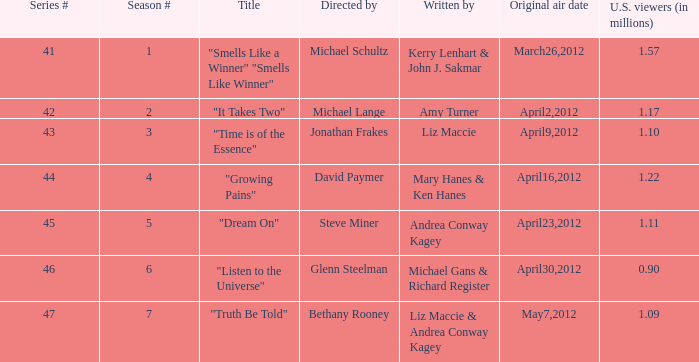Could you help me parse every detail presented in this table? {'header': ['Series #', 'Season #', 'Title', 'Directed by', 'Written by', 'Original air date', 'U.S. viewers (in millions)'], 'rows': [['41', '1', '"Smells Like a Winner" "Smells Like Winner"', 'Michael Schultz', 'Kerry Lenhart & John J. Sakmar', 'March26,2012', '1.57'], ['42', '2', '"It Takes Two"', 'Michael Lange', 'Amy Turner', 'April2,2012', '1.17'], ['43', '3', '"Time is of the Essence"', 'Jonathan Frakes', 'Liz Maccie', 'April9,2012', '1.10'], ['44', '4', '"Growing Pains"', 'David Paymer', 'Mary Hanes & Ken Hanes', 'April16,2012', '1.22'], ['45', '5', '"Dream On"', 'Steve Miner', 'Andrea Conway Kagey', 'April23,2012', '1.11'], ['46', '6', '"Listen to the Universe"', 'Glenn Steelman', 'Michael Gans & Richard Register', 'April30,2012', '0.90'], ['47', '7', '"Truth Be Told"', 'Bethany Rooney', 'Liz Maccie & Andrea Conway Kagey', 'May7,2012', '1.09']]} What is the title of the episode/s written by Michael Gans & Richard Register? "Listen to the Universe". 